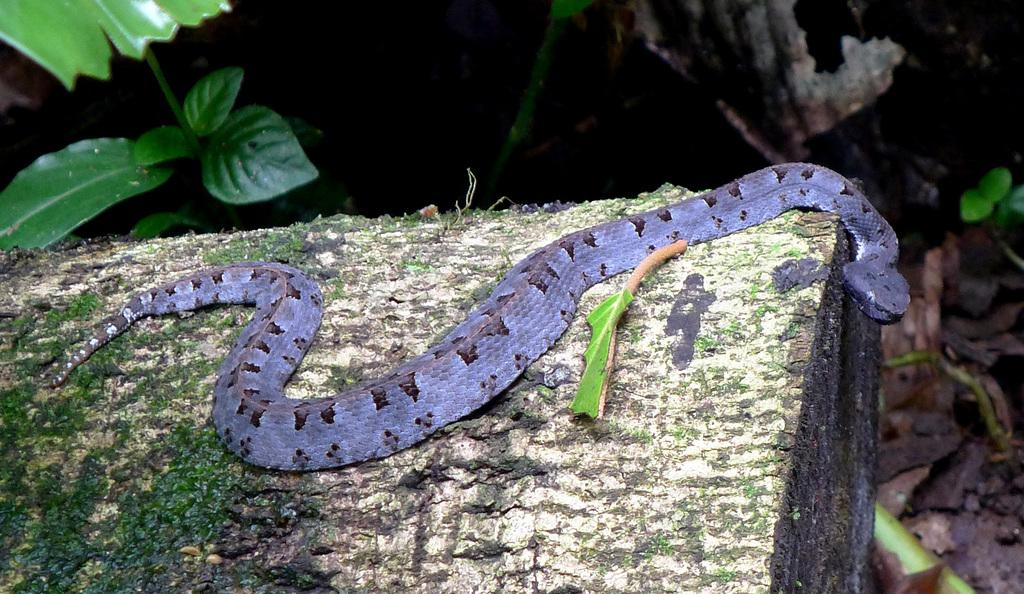What animal is on the platform in the image? There is a snake on a platform in the image. What type of vegetation is present in the image? There are leaves in the image. What is the color of the background in the image? The background of the image is dark. What type of honey is the snake eating in the image? There is no honey present in the image; it features a snake on a platform with leaves in the background. 